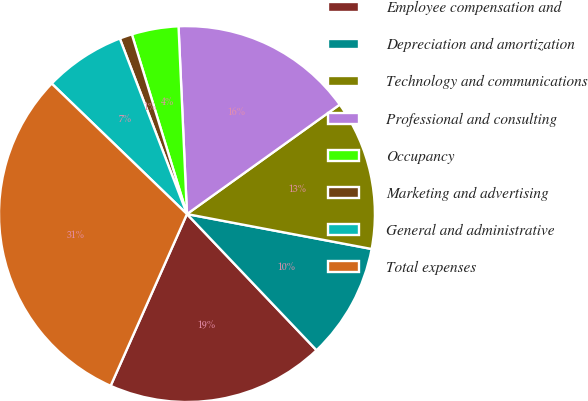Convert chart. <chart><loc_0><loc_0><loc_500><loc_500><pie_chart><fcel>Employee compensation and<fcel>Depreciation and amortization<fcel>Technology and communications<fcel>Professional and consulting<fcel>Occupancy<fcel>Marketing and advertising<fcel>General and administrative<fcel>Total expenses<nl><fcel>18.76%<fcel>9.92%<fcel>12.87%<fcel>15.82%<fcel>4.02%<fcel>1.08%<fcel>6.97%<fcel>30.56%<nl></chart> 